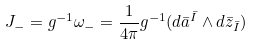<formula> <loc_0><loc_0><loc_500><loc_500>J _ { - } = g ^ { - 1 } \omega _ { - } = \frac { 1 } { 4 \pi } g ^ { - 1 } ( d \bar { a } ^ { \bar { I } } \wedge d \bar { z } _ { \bar { I } } )</formula> 